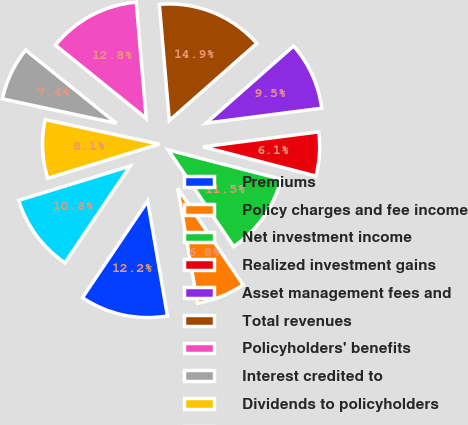Convert chart. <chart><loc_0><loc_0><loc_500><loc_500><pie_chart><fcel>Premiums<fcel>Policy charges and fee income<fcel>Net investment income<fcel>Realized investment gains<fcel>Asset management fees and<fcel>Total revenues<fcel>Policyholders' benefits<fcel>Interest credited to<fcel>Dividends to policyholders<fcel>General and administrative<nl><fcel>12.16%<fcel>6.76%<fcel>11.49%<fcel>6.08%<fcel>9.46%<fcel>14.86%<fcel>12.84%<fcel>7.43%<fcel>8.11%<fcel>10.81%<nl></chart> 